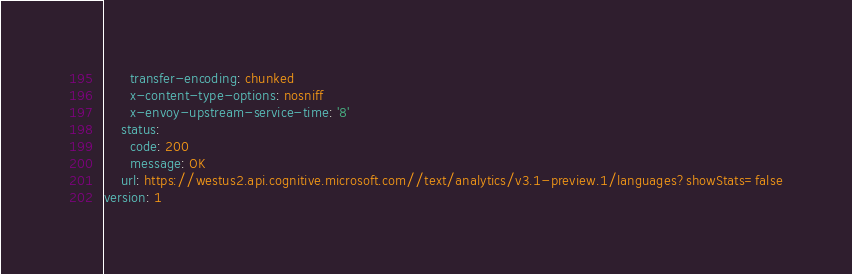<code> <loc_0><loc_0><loc_500><loc_500><_YAML_>      transfer-encoding: chunked
      x-content-type-options: nosniff
      x-envoy-upstream-service-time: '8'
    status:
      code: 200
      message: OK
    url: https://westus2.api.cognitive.microsoft.com//text/analytics/v3.1-preview.1/languages?showStats=false
version: 1
</code> 